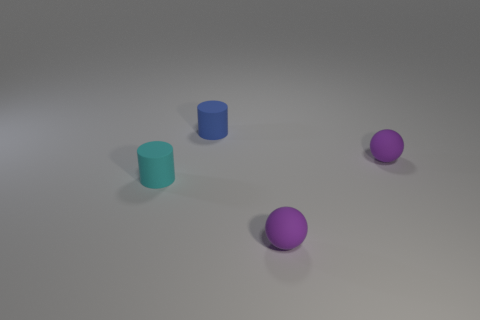Add 1 tiny purple rubber balls. How many objects exist? 5 Subtract all big red metal things. Subtract all small balls. How many objects are left? 2 Add 3 small matte spheres. How many small matte spheres are left? 5 Add 2 cyan cylinders. How many cyan cylinders exist? 3 Subtract 1 cyan cylinders. How many objects are left? 3 